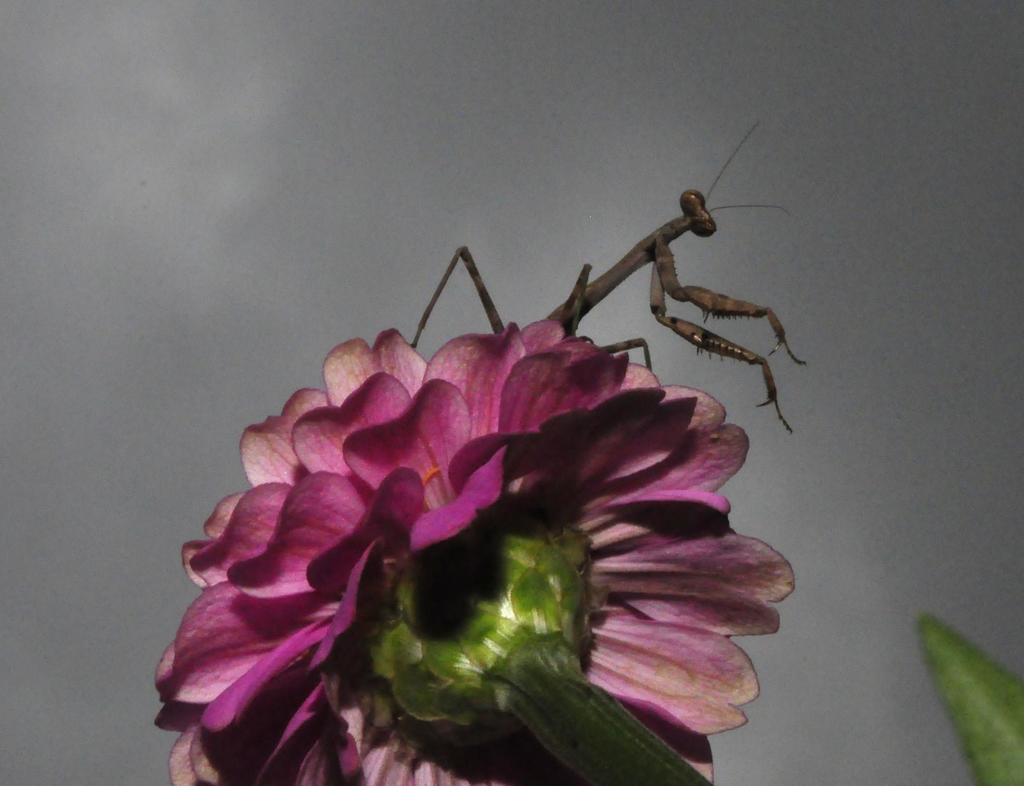What is the main subject of the image? There is a flower in the image. Is there anything else present on the flower? Yes, there is an insect on the flower. What can be seen in the background of the image? The sky is visible in the background of the image. What type of coal is being used to fuel the party in the image? There is no party or coal present in the image; it features a flower with an insect and a visible sky in the background. 